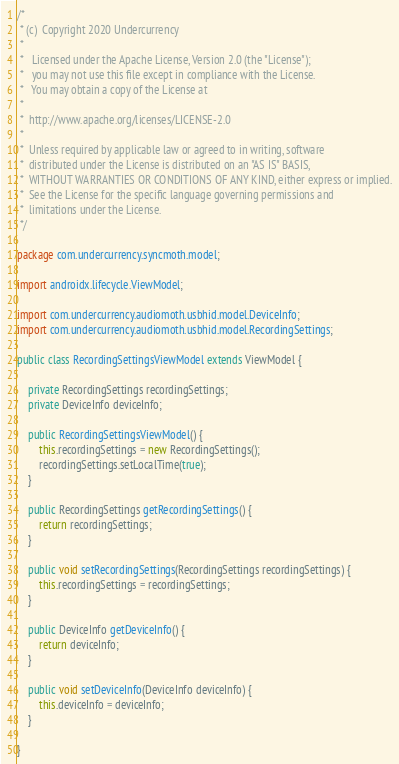Convert code to text. <code><loc_0><loc_0><loc_500><loc_500><_Java_>/*
 * (c)  Copyright 2020 Undercurrency
 *
 *   Licensed under the Apache License, Version 2.0 (the "License");
 *   you may not use this file except in compliance with the License.
 *   You may obtain a copy of the License at
 *
 *  http://www.apache.org/licenses/LICENSE-2.0
 *
 *  Unless required by applicable law or agreed to in writing, software
 *  distributed under the License is distributed on an "AS IS" BASIS,
 *  WITHOUT WARRANTIES OR CONDITIONS OF ANY KIND, either express or implied.
 *  See the License for the specific language governing permissions and
 *  limitations under the License.
 */

package com.undercurrency.syncmoth.model;

import androidx.lifecycle.ViewModel;

import com.undercurrency.audiomoth.usbhid.model.DeviceInfo;
import com.undercurrency.audiomoth.usbhid.model.RecordingSettings;

public class RecordingSettingsViewModel extends ViewModel {

    private RecordingSettings recordingSettings;
    private DeviceInfo deviceInfo;

    public RecordingSettingsViewModel() {
        this.recordingSettings = new RecordingSettings();
        recordingSettings.setLocalTime(true);
    }

    public RecordingSettings getRecordingSettings() {
        return recordingSettings;
    }

    public void setRecordingSettings(RecordingSettings recordingSettings) {
        this.recordingSettings = recordingSettings;
    }

    public DeviceInfo getDeviceInfo() {
        return deviceInfo;
    }

    public void setDeviceInfo(DeviceInfo deviceInfo) {
        this.deviceInfo = deviceInfo;
    }

}
</code> 